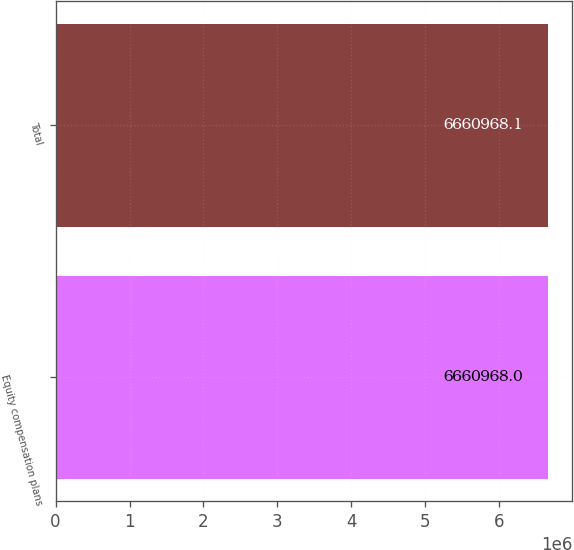Convert chart. <chart><loc_0><loc_0><loc_500><loc_500><bar_chart><fcel>Equity compensation plans<fcel>Total<nl><fcel>6.66097e+06<fcel>6.66097e+06<nl></chart> 